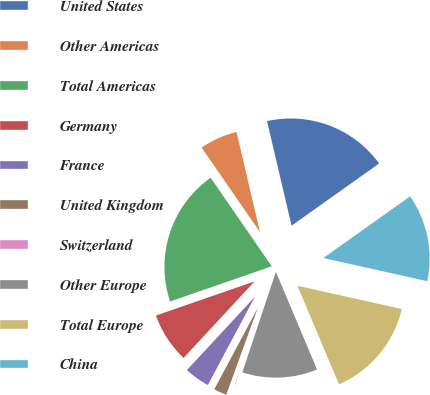Convert chart to OTSL. <chart><loc_0><loc_0><loc_500><loc_500><pie_chart><fcel>United States<fcel>Other Americas<fcel>Total Americas<fcel>Germany<fcel>France<fcel>United Kingdom<fcel>Switzerland<fcel>Other Europe<fcel>Total Europe<fcel>China<nl><fcel>18.84%<fcel>5.95%<fcel>20.69%<fcel>7.79%<fcel>4.1%<fcel>2.26%<fcel>0.42%<fcel>11.47%<fcel>15.16%<fcel>13.32%<nl></chart> 